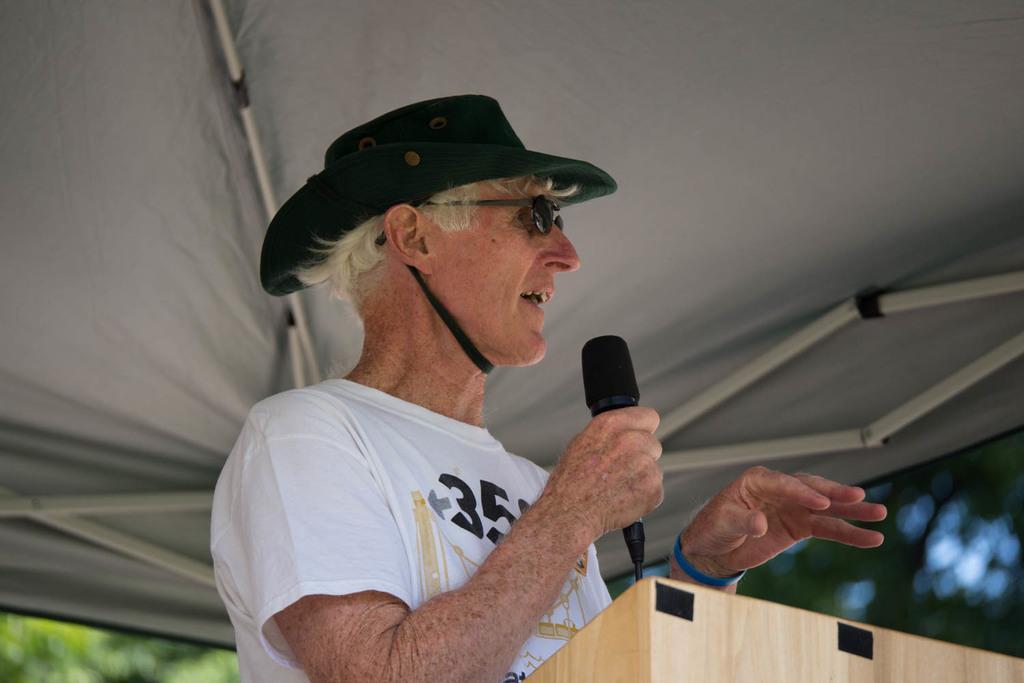In one or two sentences, can you explain what this image depicts? In this image I can see a person wearing the hat and holding the mic and he is under the tent. 